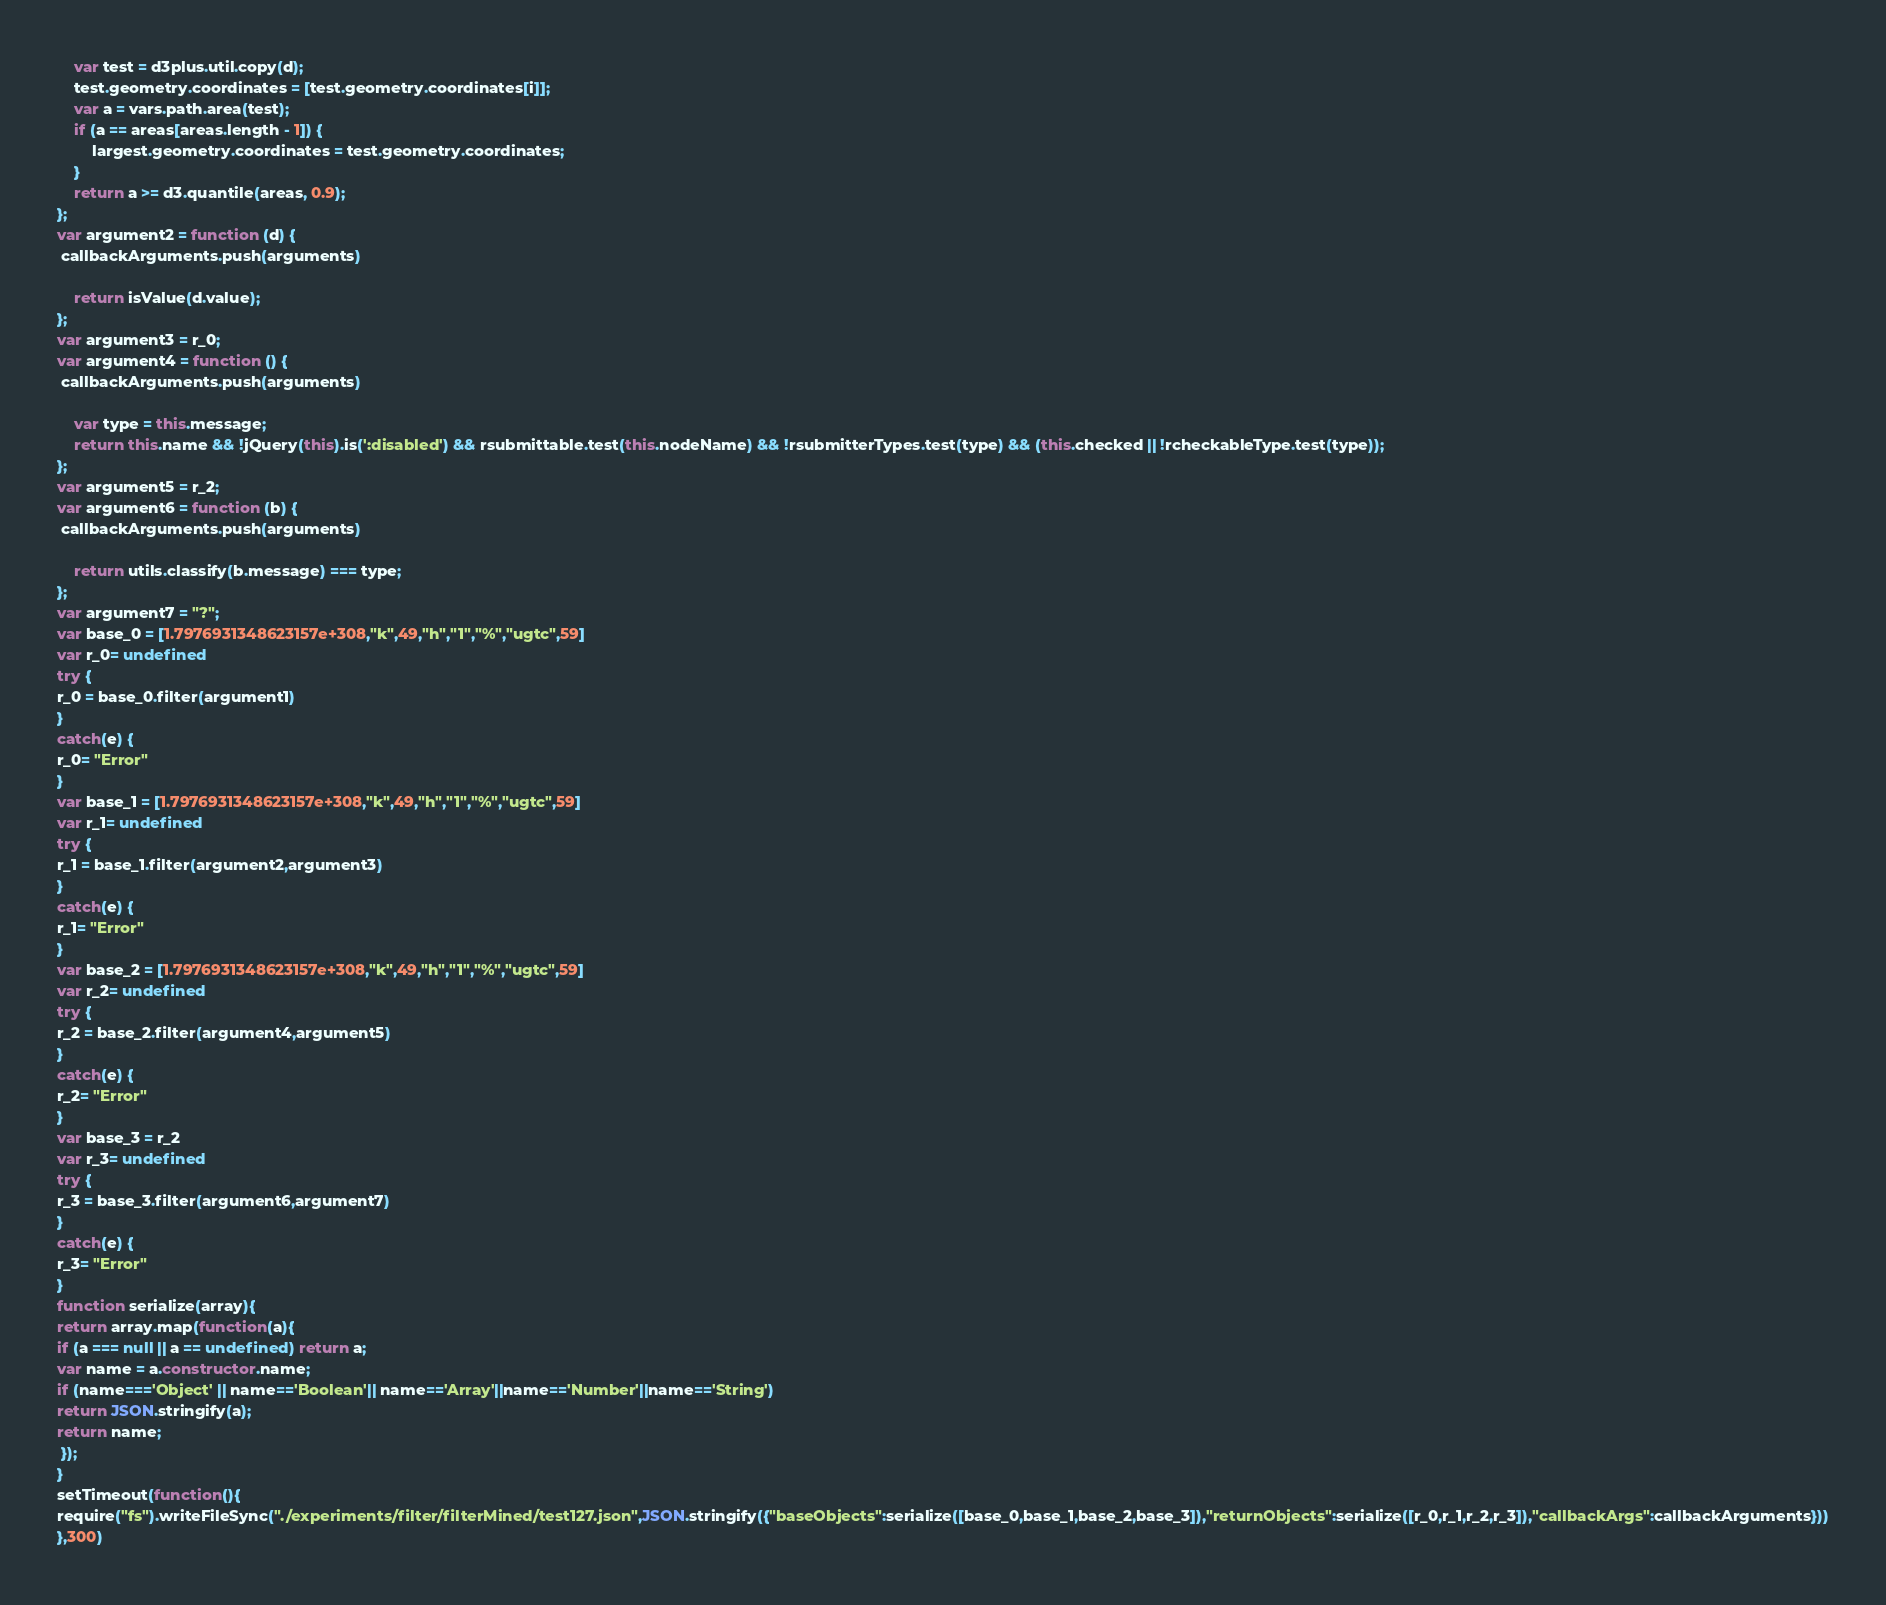<code> <loc_0><loc_0><loc_500><loc_500><_JavaScript_>
    var test = d3plus.util.copy(d);
    test.geometry.coordinates = [test.geometry.coordinates[i]];
    var a = vars.path.area(test);
    if (a == areas[areas.length - 1]) {
        largest.geometry.coordinates = test.geometry.coordinates;
    }
    return a >= d3.quantile(areas, 0.9);
};
var argument2 = function (d) {
 callbackArguments.push(arguments) 

    return isValue(d.value);
};
var argument3 = r_0;
var argument4 = function () {
 callbackArguments.push(arguments) 

    var type = this.message;
    return this.name && !jQuery(this).is(':disabled') && rsubmittable.test(this.nodeName) && !rsubmitterTypes.test(type) && (this.checked || !rcheckableType.test(type));
};
var argument5 = r_2;
var argument6 = function (b) {
 callbackArguments.push(arguments) 

    return utils.classify(b.message) === type;
};
var argument7 = "?";
var base_0 = [1.7976931348623157e+308,"k",49,"h","1","%","ugtc",59]
var r_0= undefined
try {
r_0 = base_0.filter(argument1)
}
catch(e) {
r_0= "Error"
}
var base_1 = [1.7976931348623157e+308,"k",49,"h","1","%","ugtc",59]
var r_1= undefined
try {
r_1 = base_1.filter(argument2,argument3)
}
catch(e) {
r_1= "Error"
}
var base_2 = [1.7976931348623157e+308,"k",49,"h","1","%","ugtc",59]
var r_2= undefined
try {
r_2 = base_2.filter(argument4,argument5)
}
catch(e) {
r_2= "Error"
}
var base_3 = r_2
var r_3= undefined
try {
r_3 = base_3.filter(argument6,argument7)
}
catch(e) {
r_3= "Error"
}
function serialize(array){
return array.map(function(a){
if (a === null || a == undefined) return a;
var name = a.constructor.name;
if (name==='Object' || name=='Boolean'|| name=='Array'||name=='Number'||name=='String')
return JSON.stringify(a);
return name;
 });
}
setTimeout(function(){
require("fs").writeFileSync("./experiments/filter/filterMined/test127.json",JSON.stringify({"baseObjects":serialize([base_0,base_1,base_2,base_3]),"returnObjects":serialize([r_0,r_1,r_2,r_3]),"callbackArgs":callbackArguments}))
},300)</code> 